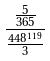<formula> <loc_0><loc_0><loc_500><loc_500>\frac { \frac { 5 } { 3 6 5 } } { \frac { 4 4 8 ^ { 1 1 9 } } { 3 } }</formula> 